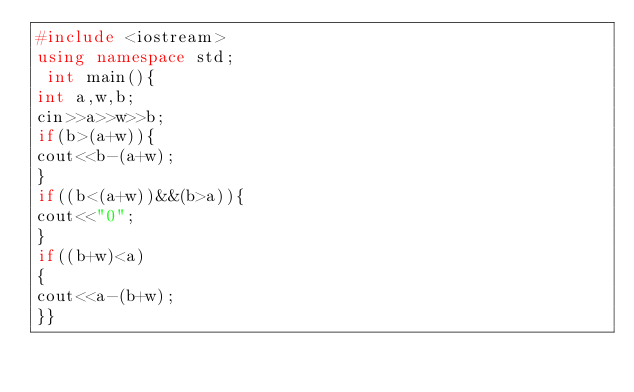<code> <loc_0><loc_0><loc_500><loc_500><_C++_>#include <iostream> 
using namespace std;
 int main(){ 
int a,w,b;
cin>>a>>w>>b;
if(b>(a+w)){
cout<<b-(a+w);
}
if((b<(a+w))&&(b>a)){
cout<<"0";
}
if((b+w)<a)
{
cout<<a-(b+w);
}}</code> 